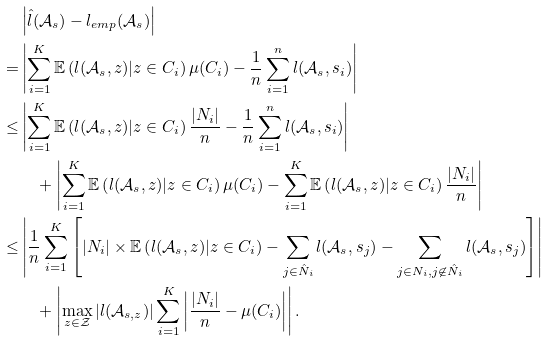Convert formula to latex. <formula><loc_0><loc_0><loc_500><loc_500>& \left | \hat { l } ( \mathcal { A } _ { s } ) - l _ { e m p } ( \mathcal { A } _ { s } ) \right | \\ = & \left | \sum _ { i = 1 } ^ { K } \mathbb { E } \left ( l ( \mathcal { A } _ { s } , z ) | z \in C _ { i } \right ) \mu ( C _ { i } ) - \frac { 1 } { n } \sum _ { i = 1 } ^ { n } l ( \mathcal { A } _ { s } , s _ { i } ) \right | \\ { \leq } & \left | \sum _ { i = 1 } ^ { K } \mathbb { E } \left ( l ( \mathcal { A } _ { s } , z ) | z \in C _ { i } \right ) \frac { | N _ { i } | } { n } - \frac { 1 } { n } \sum _ { i = 1 } ^ { n } l ( \mathcal { A } _ { s } , s _ { i } ) \right | \\ & \quad + \left | \sum _ { i = 1 } ^ { K } \mathbb { E } \left ( l ( \mathcal { A } _ { s } , z ) | z \in C _ { i } \right ) \mu ( C _ { i } ) - \sum _ { i = 1 } ^ { K } \mathbb { E } \left ( l ( \mathcal { A } _ { s } , z ) | z \in C _ { i } \right ) \frac { | N _ { i } | } { n } \right | \\ \leq & \left | \frac { 1 } { n } \sum _ { i = 1 } ^ { K } \left [ | N _ { i } | \times \mathbb { E } \left ( l ( \mathcal { A } _ { s } , z ) | z \in C _ { i } \right ) - \sum _ { j \in \hat { N } _ { i } } l ( \mathcal { A } _ { s } , s _ { j } ) - \sum _ { j \in N _ { i } , j \not \in \hat { N } _ { i } } l ( \mathcal { A } _ { s } , s _ { j } ) \right ] \right | \\ & \quad + \left | \max _ { z \in \mathcal { Z } } | l ( \mathcal { A } _ { s , z } ) | \sum _ { i = 1 } ^ { K } \left | \frac { | N _ { i } | } { n } - \mu ( C _ { i } ) \right | \right | .</formula> 